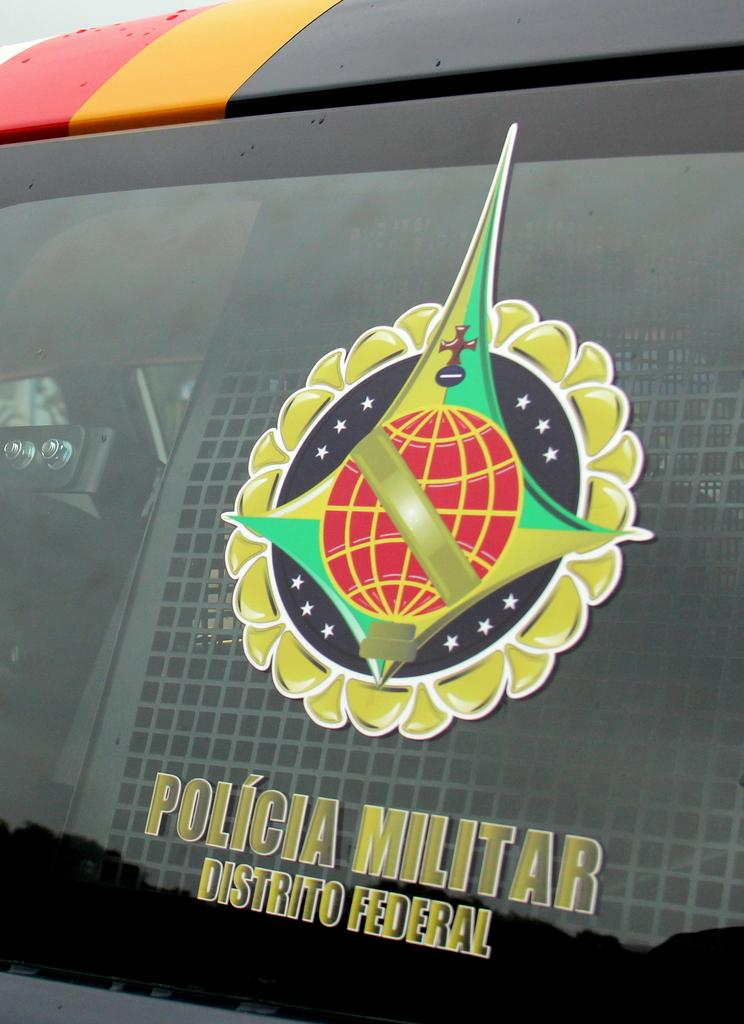<image>
Present a compact description of the photo's key features. A picture on a window that reads Policia Militar Distrito Federal 